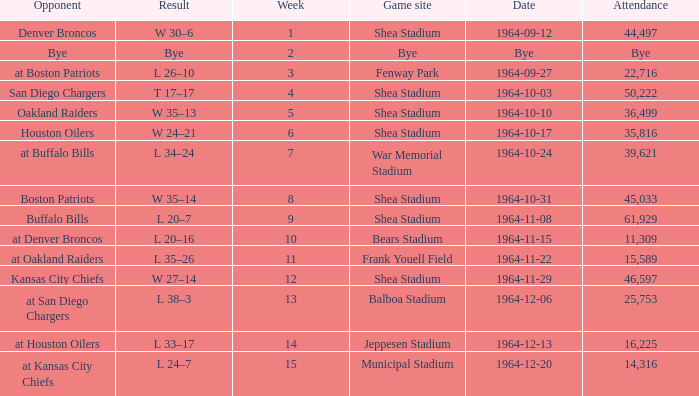Where did the Jet's play with an attendance of 11,309? Bears Stadium. 